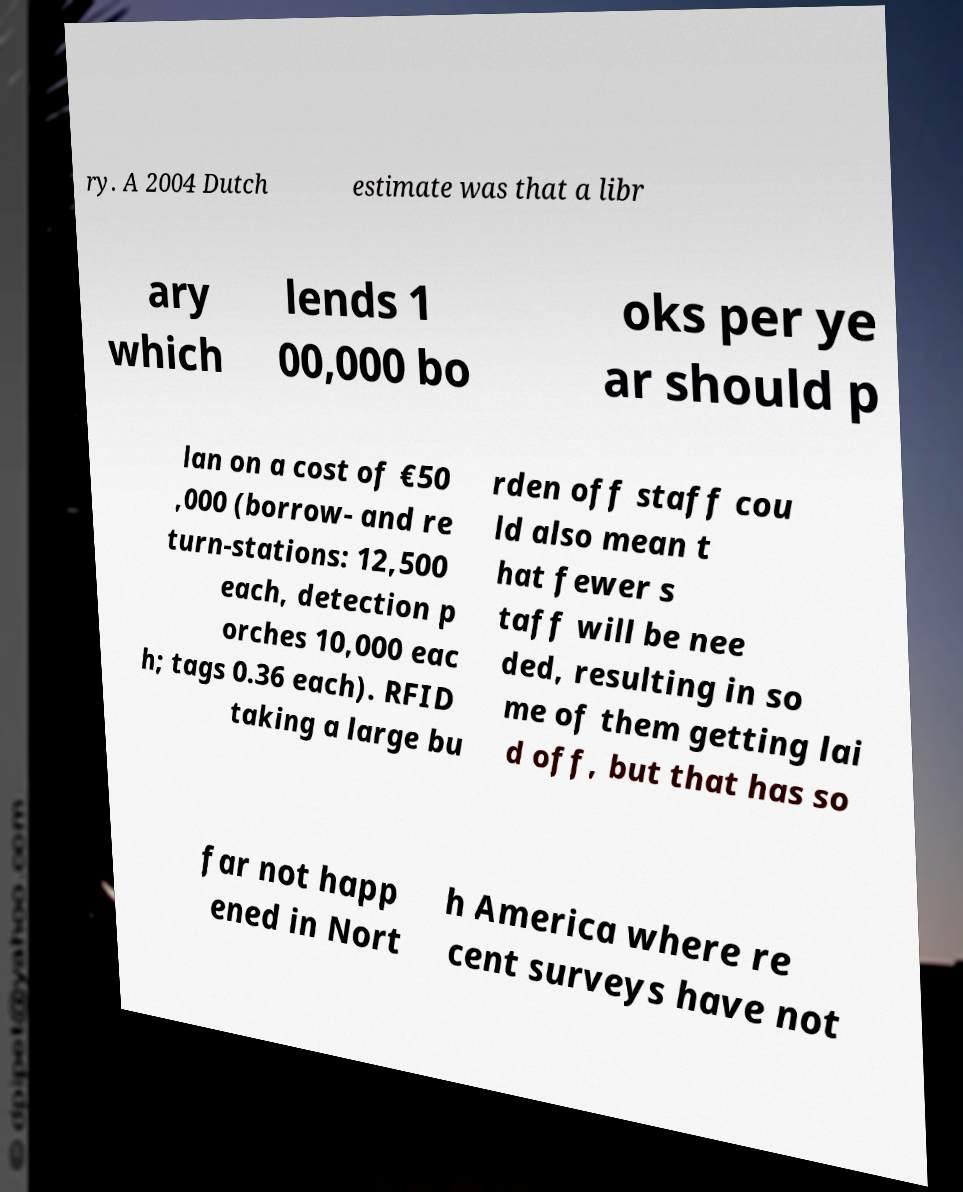Please identify and transcribe the text found in this image. ry. A 2004 Dutch estimate was that a libr ary which lends 1 00,000 bo oks per ye ar should p lan on a cost of €50 ,000 (borrow- and re turn-stations: 12,500 each, detection p orches 10,000 eac h; tags 0.36 each). RFID taking a large bu rden off staff cou ld also mean t hat fewer s taff will be nee ded, resulting in so me of them getting lai d off, but that has so far not happ ened in Nort h America where re cent surveys have not 